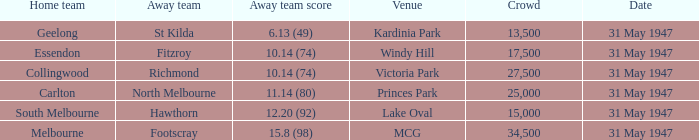What day is south melbourne at home? 31 May 1947. 